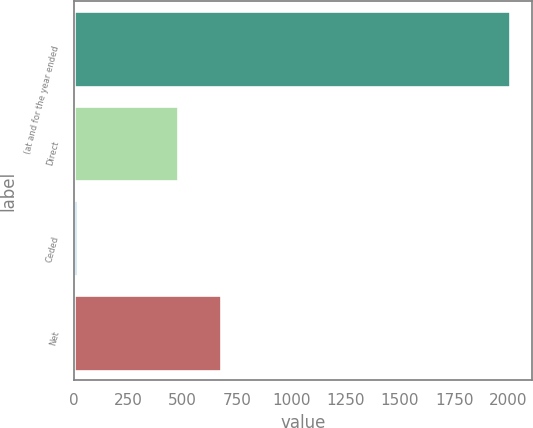Convert chart. <chart><loc_0><loc_0><loc_500><loc_500><bar_chart><fcel>(at and for the year ended<fcel>Direct<fcel>Ceded<fcel>Net<nl><fcel>2008<fcel>478<fcel>12<fcel>677.6<nl></chart> 